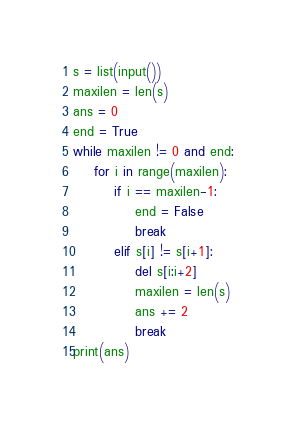Convert code to text. <code><loc_0><loc_0><loc_500><loc_500><_Python_>s = list(input())
maxilen = len(s)
ans = 0
end = True
while maxilen != 0 and end:
    for i in range(maxilen):
        if i == maxilen-1:
            end = False
            break
        elif s[i] != s[i+1]:
            del s[i:i+2]
            maxilen = len(s)
            ans += 2
            break
print(ans)</code> 